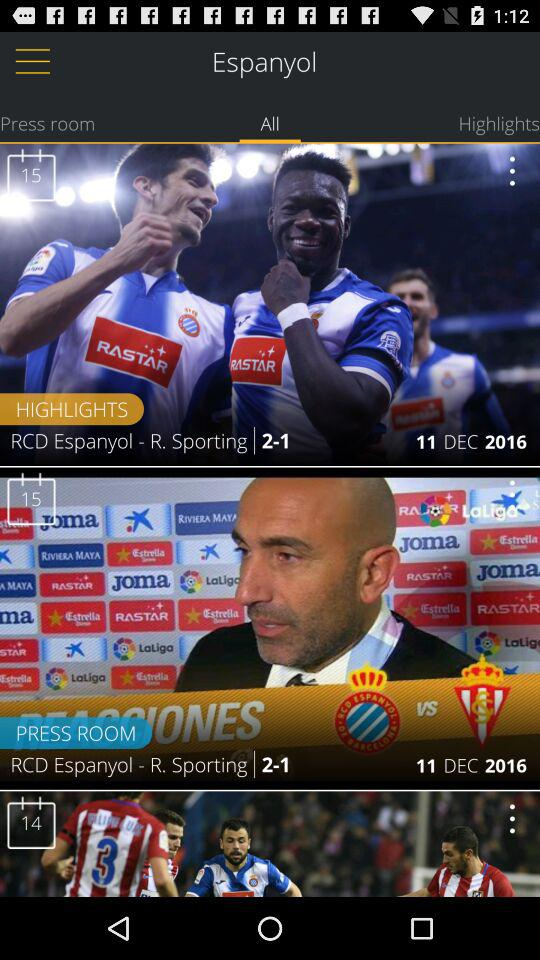What tab is selected? The selected tab is "All". 